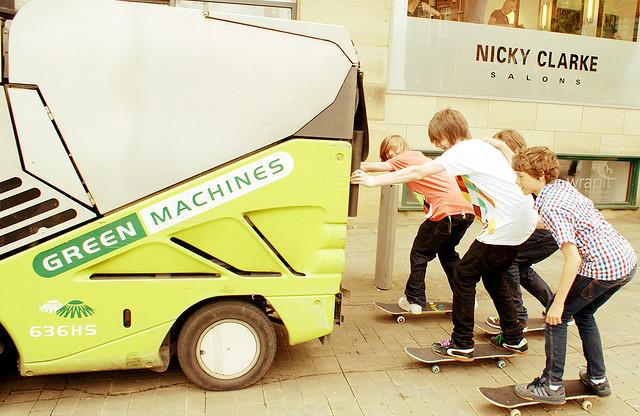What are these people holding on to?
Be succinct. Bus. What advertisement is on this bus?
Give a very brief answer. Green machines. What are the kids standing on?
Quick response, please. Skateboards. Are these kids pushing this vehicle?
Short answer required. No. 